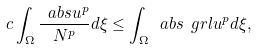<formula> <loc_0><loc_0><loc_500><loc_500>c \int _ { \Omega } \frac { \ a b s { u } ^ { p } } { N ^ { p } } d \xi \leq \int _ { \Omega } \ a b s { \ g r l u } ^ { p } d \xi ,</formula> 